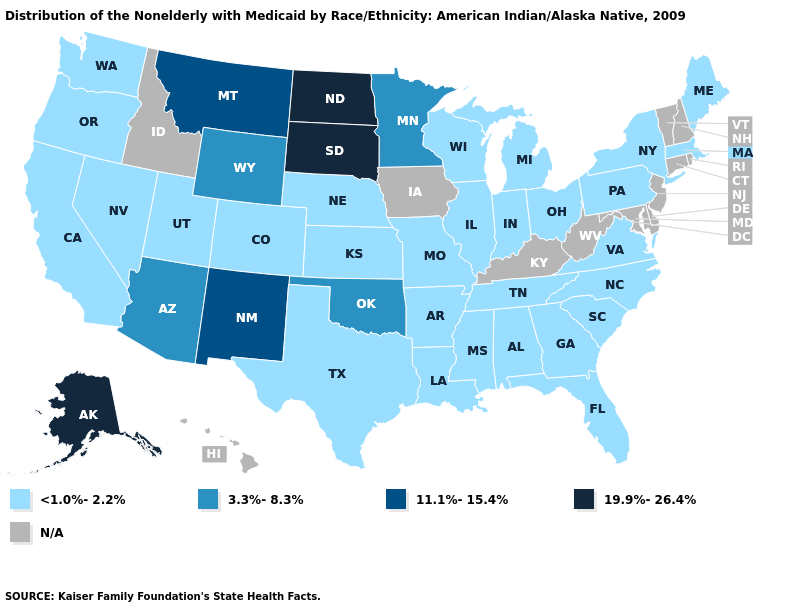Is the legend a continuous bar?
Give a very brief answer. No. What is the value of Virginia?
Write a very short answer. <1.0%-2.2%. Does Tennessee have the lowest value in the USA?
Write a very short answer. Yes. Is the legend a continuous bar?
Quick response, please. No. Which states have the highest value in the USA?
Concise answer only. Alaska, North Dakota, South Dakota. Which states have the highest value in the USA?
Keep it brief. Alaska, North Dakota, South Dakota. Name the states that have a value in the range 19.9%-26.4%?
Quick response, please. Alaska, North Dakota, South Dakota. Name the states that have a value in the range 11.1%-15.4%?
Be succinct. Montana, New Mexico. Does the map have missing data?
Answer briefly. Yes. Name the states that have a value in the range <1.0%-2.2%?
Answer briefly. Alabama, Arkansas, California, Colorado, Florida, Georgia, Illinois, Indiana, Kansas, Louisiana, Maine, Massachusetts, Michigan, Mississippi, Missouri, Nebraska, Nevada, New York, North Carolina, Ohio, Oregon, Pennsylvania, South Carolina, Tennessee, Texas, Utah, Virginia, Washington, Wisconsin. Among the states that border Nebraska , which have the lowest value?
Short answer required. Colorado, Kansas, Missouri. Does Indiana have the lowest value in the USA?
Short answer required. Yes. Name the states that have a value in the range N/A?
Keep it brief. Connecticut, Delaware, Hawaii, Idaho, Iowa, Kentucky, Maryland, New Hampshire, New Jersey, Rhode Island, Vermont, West Virginia. Name the states that have a value in the range N/A?
Be succinct. Connecticut, Delaware, Hawaii, Idaho, Iowa, Kentucky, Maryland, New Hampshire, New Jersey, Rhode Island, Vermont, West Virginia. 